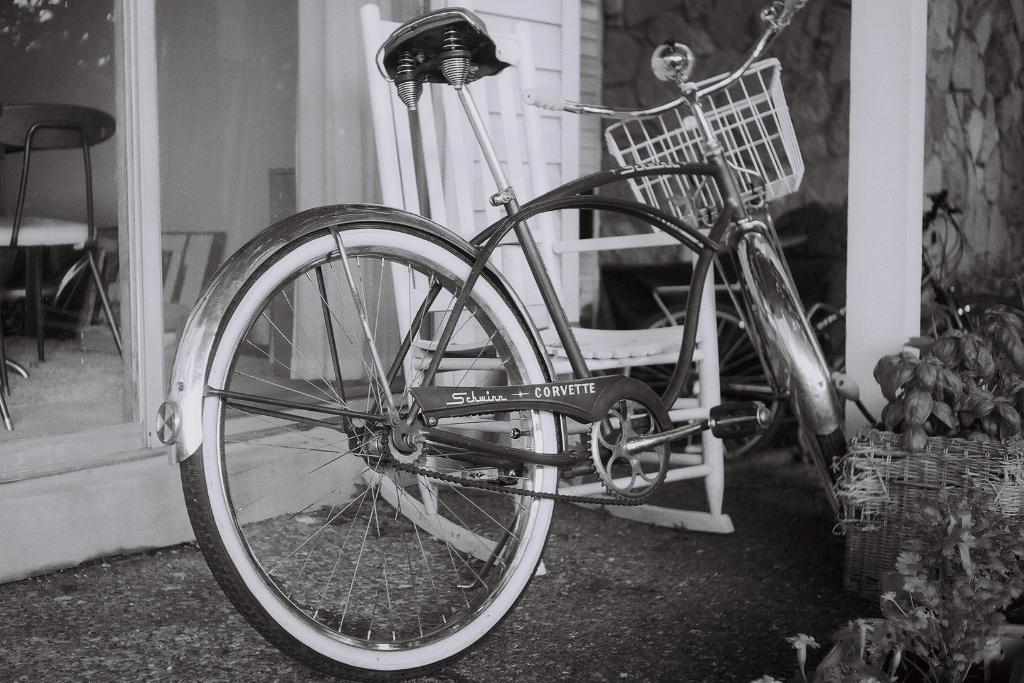How many bicycles are in the image? There are two bicycles in the image. What else can be seen in the image besides the bicycles? There are plants, a glass door, and a chair in the background of the image. What is the color scheme of the image? The image is in black and white. Can you see any wounds on the bicycles in the image? There are no wounds visible on the bicycles in the image, as they are inanimate objects. What type of humor is being displayed in the image? There is no humor present in the image, as it is a straightforward depiction of bicycles, plants, and other objects. 